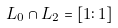Convert formula to latex. <formula><loc_0><loc_0><loc_500><loc_500>L _ { 0 } \cap L _ { 2 } = [ 1 \colon 1 ]</formula> 